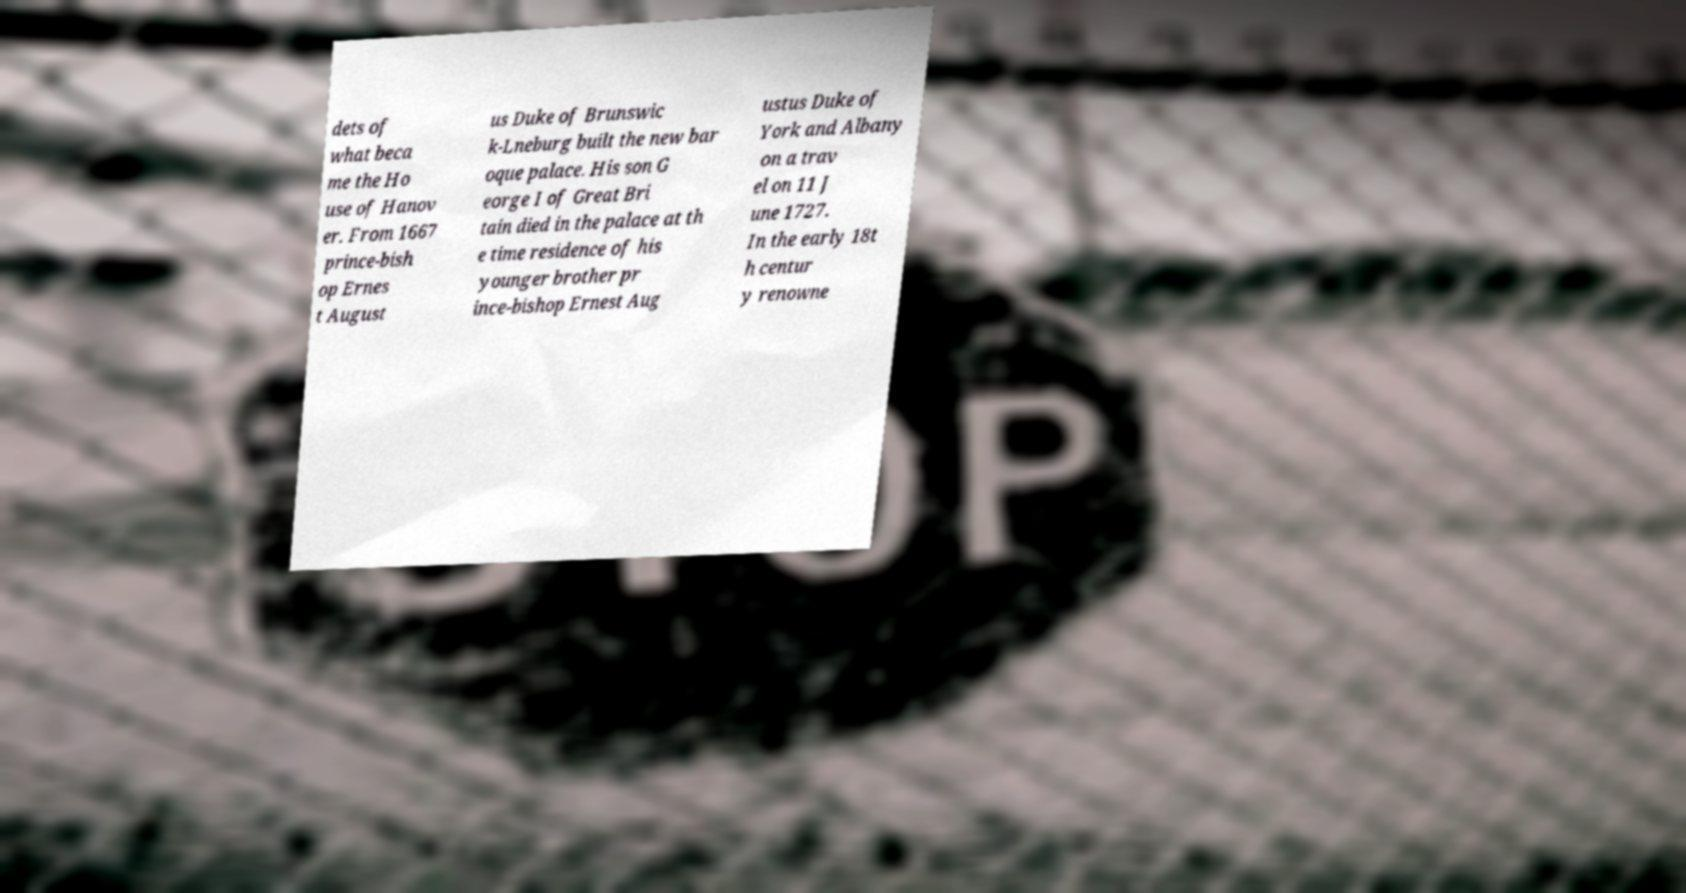There's text embedded in this image that I need extracted. Can you transcribe it verbatim? dets of what beca me the Ho use of Hanov er. From 1667 prince-bish op Ernes t August us Duke of Brunswic k-Lneburg built the new bar oque palace. His son G eorge I of Great Bri tain died in the palace at th e time residence of his younger brother pr ince-bishop Ernest Aug ustus Duke of York and Albany on a trav el on 11 J une 1727. In the early 18t h centur y renowne 